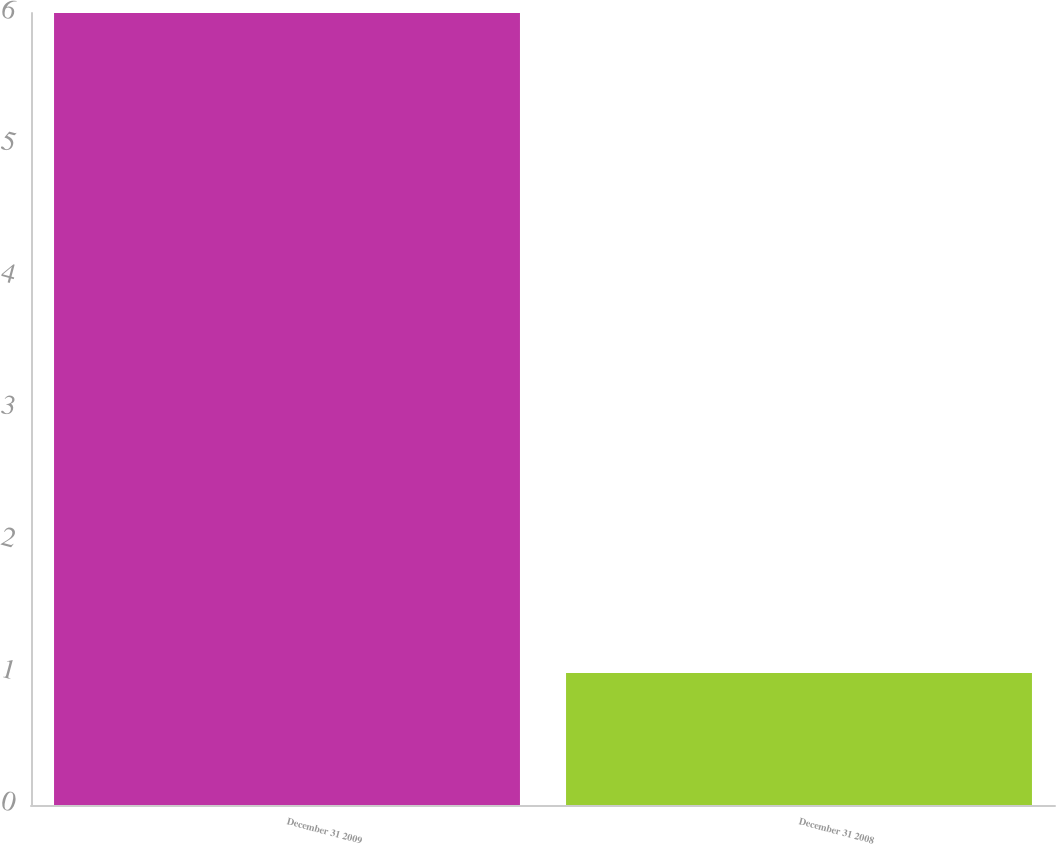<chart> <loc_0><loc_0><loc_500><loc_500><bar_chart><fcel>December 31 2009<fcel>December 31 2008<nl><fcel>6<fcel>1<nl></chart> 